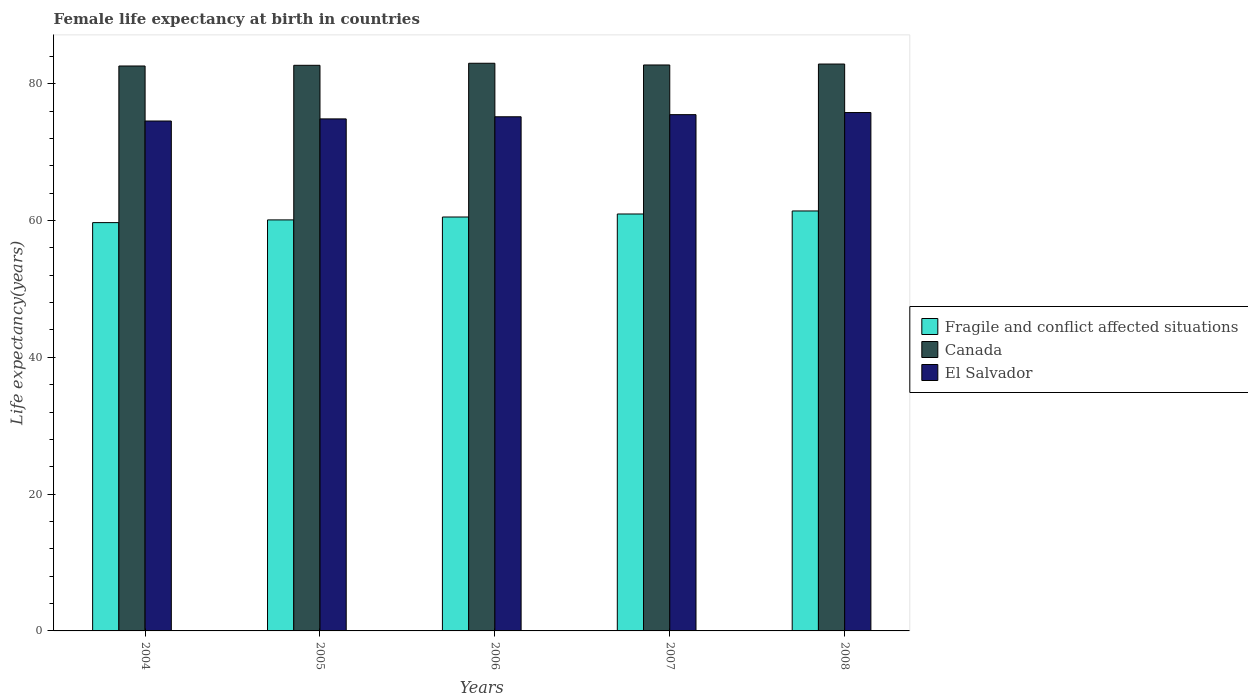Are the number of bars per tick equal to the number of legend labels?
Make the answer very short. Yes. How many bars are there on the 2nd tick from the left?
Your response must be concise. 3. How many bars are there on the 4th tick from the right?
Keep it short and to the point. 3. In how many cases, is the number of bars for a given year not equal to the number of legend labels?
Ensure brevity in your answer.  0. What is the female life expectancy at birth in Fragile and conflict affected situations in 2008?
Give a very brief answer. 61.4. Across all years, what is the maximum female life expectancy at birth in El Salvador?
Offer a terse response. 75.79. Across all years, what is the minimum female life expectancy at birth in Fragile and conflict affected situations?
Your response must be concise. 59.7. What is the total female life expectancy at birth in Canada in the graph?
Your answer should be very brief. 413.93. What is the difference between the female life expectancy at birth in Fragile and conflict affected situations in 2004 and that in 2005?
Keep it short and to the point. -0.4. What is the difference between the female life expectancy at birth in El Salvador in 2008 and the female life expectancy at birth in Fragile and conflict affected situations in 2005?
Make the answer very short. 15.7. What is the average female life expectancy at birth in Fragile and conflict affected situations per year?
Your answer should be very brief. 60.54. In the year 2005, what is the difference between the female life expectancy at birth in El Salvador and female life expectancy at birth in Canada?
Ensure brevity in your answer.  -7.84. What is the ratio of the female life expectancy at birth in Fragile and conflict affected situations in 2004 to that in 2007?
Offer a very short reply. 0.98. Is the female life expectancy at birth in Canada in 2005 less than that in 2006?
Your answer should be compact. Yes. What is the difference between the highest and the second highest female life expectancy at birth in El Salvador?
Make the answer very short. 0.31. What is the difference between the highest and the lowest female life expectancy at birth in Fragile and conflict affected situations?
Offer a very short reply. 1.71. In how many years, is the female life expectancy at birth in El Salvador greater than the average female life expectancy at birth in El Salvador taken over all years?
Keep it short and to the point. 3. Is the sum of the female life expectancy at birth in Fragile and conflict affected situations in 2004 and 2007 greater than the maximum female life expectancy at birth in El Salvador across all years?
Ensure brevity in your answer.  Yes. What does the 3rd bar from the left in 2007 represents?
Ensure brevity in your answer.  El Salvador. What does the 2nd bar from the right in 2005 represents?
Ensure brevity in your answer.  Canada. How many bars are there?
Ensure brevity in your answer.  15. How many years are there in the graph?
Provide a succinct answer. 5. What is the difference between two consecutive major ticks on the Y-axis?
Give a very brief answer. 20. Are the values on the major ticks of Y-axis written in scientific E-notation?
Provide a short and direct response. No. Where does the legend appear in the graph?
Offer a terse response. Center right. How many legend labels are there?
Offer a terse response. 3. How are the legend labels stacked?
Give a very brief answer. Vertical. What is the title of the graph?
Your answer should be very brief. Female life expectancy at birth in countries. What is the label or title of the X-axis?
Your response must be concise. Years. What is the label or title of the Y-axis?
Give a very brief answer. Life expectancy(years). What is the Life expectancy(years) of Fragile and conflict affected situations in 2004?
Ensure brevity in your answer.  59.7. What is the Life expectancy(years) in Canada in 2004?
Ensure brevity in your answer.  82.6. What is the Life expectancy(years) of El Salvador in 2004?
Offer a terse response. 74.56. What is the Life expectancy(years) of Fragile and conflict affected situations in 2005?
Give a very brief answer. 60.1. What is the Life expectancy(years) of Canada in 2005?
Ensure brevity in your answer.  82.7. What is the Life expectancy(years) of El Salvador in 2005?
Give a very brief answer. 74.86. What is the Life expectancy(years) of Fragile and conflict affected situations in 2006?
Ensure brevity in your answer.  60.52. What is the Life expectancy(years) of Canada in 2006?
Your answer should be very brief. 83. What is the Life expectancy(years) of El Salvador in 2006?
Your response must be concise. 75.18. What is the Life expectancy(years) of Fragile and conflict affected situations in 2007?
Offer a very short reply. 60.96. What is the Life expectancy(years) in Canada in 2007?
Make the answer very short. 82.75. What is the Life expectancy(years) of El Salvador in 2007?
Your response must be concise. 75.49. What is the Life expectancy(years) in Fragile and conflict affected situations in 2008?
Your response must be concise. 61.4. What is the Life expectancy(years) of Canada in 2008?
Your response must be concise. 82.89. What is the Life expectancy(years) of El Salvador in 2008?
Ensure brevity in your answer.  75.79. Across all years, what is the maximum Life expectancy(years) in Fragile and conflict affected situations?
Offer a very short reply. 61.4. Across all years, what is the maximum Life expectancy(years) in El Salvador?
Offer a terse response. 75.79. Across all years, what is the minimum Life expectancy(years) of Fragile and conflict affected situations?
Provide a succinct answer. 59.7. Across all years, what is the minimum Life expectancy(years) in Canada?
Provide a short and direct response. 82.6. Across all years, what is the minimum Life expectancy(years) of El Salvador?
Your answer should be compact. 74.56. What is the total Life expectancy(years) in Fragile and conflict affected situations in the graph?
Make the answer very short. 302.68. What is the total Life expectancy(years) of Canada in the graph?
Give a very brief answer. 413.93. What is the total Life expectancy(years) in El Salvador in the graph?
Your answer should be compact. 375.88. What is the difference between the Life expectancy(years) of Fragile and conflict affected situations in 2004 and that in 2005?
Keep it short and to the point. -0.4. What is the difference between the Life expectancy(years) of Canada in 2004 and that in 2005?
Your response must be concise. -0.1. What is the difference between the Life expectancy(years) in El Salvador in 2004 and that in 2005?
Give a very brief answer. -0.31. What is the difference between the Life expectancy(years) of Fragile and conflict affected situations in 2004 and that in 2006?
Make the answer very short. -0.82. What is the difference between the Life expectancy(years) in El Salvador in 2004 and that in 2006?
Offer a very short reply. -0.62. What is the difference between the Life expectancy(years) of Fragile and conflict affected situations in 2004 and that in 2007?
Provide a short and direct response. -1.26. What is the difference between the Life expectancy(years) in Canada in 2004 and that in 2007?
Ensure brevity in your answer.  -0.15. What is the difference between the Life expectancy(years) of El Salvador in 2004 and that in 2007?
Your answer should be compact. -0.93. What is the difference between the Life expectancy(years) of Fragile and conflict affected situations in 2004 and that in 2008?
Keep it short and to the point. -1.71. What is the difference between the Life expectancy(years) of Canada in 2004 and that in 2008?
Your response must be concise. -0.29. What is the difference between the Life expectancy(years) in El Salvador in 2004 and that in 2008?
Offer a very short reply. -1.24. What is the difference between the Life expectancy(years) in Fragile and conflict affected situations in 2005 and that in 2006?
Your response must be concise. -0.42. What is the difference between the Life expectancy(years) in Canada in 2005 and that in 2006?
Make the answer very short. -0.3. What is the difference between the Life expectancy(years) of El Salvador in 2005 and that in 2006?
Give a very brief answer. -0.31. What is the difference between the Life expectancy(years) of Fragile and conflict affected situations in 2005 and that in 2007?
Make the answer very short. -0.86. What is the difference between the Life expectancy(years) in Canada in 2005 and that in 2007?
Your response must be concise. -0.05. What is the difference between the Life expectancy(years) of El Salvador in 2005 and that in 2007?
Provide a succinct answer. -0.62. What is the difference between the Life expectancy(years) of Fragile and conflict affected situations in 2005 and that in 2008?
Provide a succinct answer. -1.31. What is the difference between the Life expectancy(years) of Canada in 2005 and that in 2008?
Ensure brevity in your answer.  -0.19. What is the difference between the Life expectancy(years) of El Salvador in 2005 and that in 2008?
Your response must be concise. -0.93. What is the difference between the Life expectancy(years) in Fragile and conflict affected situations in 2006 and that in 2007?
Make the answer very short. -0.44. What is the difference between the Life expectancy(years) of Canada in 2006 and that in 2007?
Provide a succinct answer. 0.25. What is the difference between the Life expectancy(years) of El Salvador in 2006 and that in 2007?
Give a very brief answer. -0.31. What is the difference between the Life expectancy(years) of Fragile and conflict affected situations in 2006 and that in 2008?
Provide a short and direct response. -0.88. What is the difference between the Life expectancy(years) in Canada in 2006 and that in 2008?
Provide a succinct answer. 0.11. What is the difference between the Life expectancy(years) in El Salvador in 2006 and that in 2008?
Your answer should be compact. -0.62. What is the difference between the Life expectancy(years) of Fragile and conflict affected situations in 2007 and that in 2008?
Keep it short and to the point. -0.45. What is the difference between the Life expectancy(years) in Canada in 2007 and that in 2008?
Make the answer very short. -0.14. What is the difference between the Life expectancy(years) in El Salvador in 2007 and that in 2008?
Give a very brief answer. -0.31. What is the difference between the Life expectancy(years) of Fragile and conflict affected situations in 2004 and the Life expectancy(years) of Canada in 2005?
Provide a succinct answer. -23. What is the difference between the Life expectancy(years) in Fragile and conflict affected situations in 2004 and the Life expectancy(years) in El Salvador in 2005?
Your answer should be very brief. -15.17. What is the difference between the Life expectancy(years) in Canada in 2004 and the Life expectancy(years) in El Salvador in 2005?
Your answer should be compact. 7.74. What is the difference between the Life expectancy(years) of Fragile and conflict affected situations in 2004 and the Life expectancy(years) of Canada in 2006?
Offer a terse response. -23.3. What is the difference between the Life expectancy(years) of Fragile and conflict affected situations in 2004 and the Life expectancy(years) of El Salvador in 2006?
Provide a short and direct response. -15.48. What is the difference between the Life expectancy(years) in Canada in 2004 and the Life expectancy(years) in El Salvador in 2006?
Offer a terse response. 7.42. What is the difference between the Life expectancy(years) of Fragile and conflict affected situations in 2004 and the Life expectancy(years) of Canada in 2007?
Give a very brief answer. -23.05. What is the difference between the Life expectancy(years) in Fragile and conflict affected situations in 2004 and the Life expectancy(years) in El Salvador in 2007?
Offer a very short reply. -15.79. What is the difference between the Life expectancy(years) of Canada in 2004 and the Life expectancy(years) of El Salvador in 2007?
Provide a short and direct response. 7.11. What is the difference between the Life expectancy(years) in Fragile and conflict affected situations in 2004 and the Life expectancy(years) in Canada in 2008?
Make the answer very short. -23.19. What is the difference between the Life expectancy(years) of Fragile and conflict affected situations in 2004 and the Life expectancy(years) of El Salvador in 2008?
Ensure brevity in your answer.  -16.09. What is the difference between the Life expectancy(years) of Canada in 2004 and the Life expectancy(years) of El Salvador in 2008?
Your response must be concise. 6.81. What is the difference between the Life expectancy(years) of Fragile and conflict affected situations in 2005 and the Life expectancy(years) of Canada in 2006?
Keep it short and to the point. -22.9. What is the difference between the Life expectancy(years) in Fragile and conflict affected situations in 2005 and the Life expectancy(years) in El Salvador in 2006?
Your response must be concise. -15.08. What is the difference between the Life expectancy(years) in Canada in 2005 and the Life expectancy(years) in El Salvador in 2006?
Provide a succinct answer. 7.52. What is the difference between the Life expectancy(years) of Fragile and conflict affected situations in 2005 and the Life expectancy(years) of Canada in 2007?
Offer a very short reply. -22.65. What is the difference between the Life expectancy(years) in Fragile and conflict affected situations in 2005 and the Life expectancy(years) in El Salvador in 2007?
Make the answer very short. -15.39. What is the difference between the Life expectancy(years) of Canada in 2005 and the Life expectancy(years) of El Salvador in 2007?
Your answer should be very brief. 7.21. What is the difference between the Life expectancy(years) of Fragile and conflict affected situations in 2005 and the Life expectancy(years) of Canada in 2008?
Your response must be concise. -22.79. What is the difference between the Life expectancy(years) in Fragile and conflict affected situations in 2005 and the Life expectancy(years) in El Salvador in 2008?
Your response must be concise. -15.7. What is the difference between the Life expectancy(years) in Canada in 2005 and the Life expectancy(years) in El Salvador in 2008?
Offer a very short reply. 6.91. What is the difference between the Life expectancy(years) of Fragile and conflict affected situations in 2006 and the Life expectancy(years) of Canada in 2007?
Make the answer very short. -22.23. What is the difference between the Life expectancy(years) of Fragile and conflict affected situations in 2006 and the Life expectancy(years) of El Salvador in 2007?
Make the answer very short. -14.97. What is the difference between the Life expectancy(years) in Canada in 2006 and the Life expectancy(years) in El Salvador in 2007?
Offer a terse response. 7.51. What is the difference between the Life expectancy(years) in Fragile and conflict affected situations in 2006 and the Life expectancy(years) in Canada in 2008?
Give a very brief answer. -22.37. What is the difference between the Life expectancy(years) in Fragile and conflict affected situations in 2006 and the Life expectancy(years) in El Salvador in 2008?
Make the answer very short. -15.27. What is the difference between the Life expectancy(years) in Canada in 2006 and the Life expectancy(years) in El Salvador in 2008?
Make the answer very short. 7.21. What is the difference between the Life expectancy(years) in Fragile and conflict affected situations in 2007 and the Life expectancy(years) in Canada in 2008?
Your response must be concise. -21.93. What is the difference between the Life expectancy(years) of Fragile and conflict affected situations in 2007 and the Life expectancy(years) of El Salvador in 2008?
Your answer should be very brief. -14.83. What is the difference between the Life expectancy(years) in Canada in 2007 and the Life expectancy(years) in El Salvador in 2008?
Provide a short and direct response. 6.95. What is the average Life expectancy(years) of Fragile and conflict affected situations per year?
Provide a short and direct response. 60.54. What is the average Life expectancy(years) of Canada per year?
Make the answer very short. 82.79. What is the average Life expectancy(years) of El Salvador per year?
Give a very brief answer. 75.18. In the year 2004, what is the difference between the Life expectancy(years) in Fragile and conflict affected situations and Life expectancy(years) in Canada?
Your answer should be very brief. -22.9. In the year 2004, what is the difference between the Life expectancy(years) in Fragile and conflict affected situations and Life expectancy(years) in El Salvador?
Offer a terse response. -14.86. In the year 2004, what is the difference between the Life expectancy(years) of Canada and Life expectancy(years) of El Salvador?
Offer a terse response. 8.04. In the year 2005, what is the difference between the Life expectancy(years) in Fragile and conflict affected situations and Life expectancy(years) in Canada?
Provide a succinct answer. -22.6. In the year 2005, what is the difference between the Life expectancy(years) in Fragile and conflict affected situations and Life expectancy(years) in El Salvador?
Provide a short and direct response. -14.77. In the year 2005, what is the difference between the Life expectancy(years) of Canada and Life expectancy(years) of El Salvador?
Your answer should be compact. 7.83. In the year 2006, what is the difference between the Life expectancy(years) of Fragile and conflict affected situations and Life expectancy(years) of Canada?
Ensure brevity in your answer.  -22.48. In the year 2006, what is the difference between the Life expectancy(years) in Fragile and conflict affected situations and Life expectancy(years) in El Salvador?
Offer a very short reply. -14.66. In the year 2006, what is the difference between the Life expectancy(years) in Canada and Life expectancy(years) in El Salvador?
Provide a succinct answer. 7.82. In the year 2007, what is the difference between the Life expectancy(years) of Fragile and conflict affected situations and Life expectancy(years) of Canada?
Your answer should be compact. -21.79. In the year 2007, what is the difference between the Life expectancy(years) of Fragile and conflict affected situations and Life expectancy(years) of El Salvador?
Make the answer very short. -14.53. In the year 2007, what is the difference between the Life expectancy(years) in Canada and Life expectancy(years) in El Salvador?
Your answer should be very brief. 7.26. In the year 2008, what is the difference between the Life expectancy(years) of Fragile and conflict affected situations and Life expectancy(years) of Canada?
Your response must be concise. -21.48. In the year 2008, what is the difference between the Life expectancy(years) in Fragile and conflict affected situations and Life expectancy(years) in El Salvador?
Offer a very short reply. -14.39. In the year 2008, what is the difference between the Life expectancy(years) in Canada and Life expectancy(years) in El Salvador?
Your response must be concise. 7.09. What is the ratio of the Life expectancy(years) in Canada in 2004 to that in 2005?
Ensure brevity in your answer.  1. What is the ratio of the Life expectancy(years) in Fragile and conflict affected situations in 2004 to that in 2006?
Give a very brief answer. 0.99. What is the ratio of the Life expectancy(years) in El Salvador in 2004 to that in 2006?
Your answer should be very brief. 0.99. What is the ratio of the Life expectancy(years) of Fragile and conflict affected situations in 2004 to that in 2007?
Provide a succinct answer. 0.98. What is the ratio of the Life expectancy(years) in Fragile and conflict affected situations in 2004 to that in 2008?
Your answer should be compact. 0.97. What is the ratio of the Life expectancy(years) of El Salvador in 2004 to that in 2008?
Keep it short and to the point. 0.98. What is the ratio of the Life expectancy(years) of Fragile and conflict affected situations in 2005 to that in 2006?
Your answer should be compact. 0.99. What is the ratio of the Life expectancy(years) of Fragile and conflict affected situations in 2005 to that in 2007?
Keep it short and to the point. 0.99. What is the ratio of the Life expectancy(years) of Canada in 2005 to that in 2007?
Offer a terse response. 1. What is the ratio of the Life expectancy(years) of El Salvador in 2005 to that in 2007?
Make the answer very short. 0.99. What is the ratio of the Life expectancy(years) in Fragile and conflict affected situations in 2005 to that in 2008?
Your answer should be very brief. 0.98. What is the ratio of the Life expectancy(years) in Fragile and conflict affected situations in 2006 to that in 2007?
Your answer should be very brief. 0.99. What is the ratio of the Life expectancy(years) of Canada in 2006 to that in 2007?
Make the answer very short. 1. What is the ratio of the Life expectancy(years) in Fragile and conflict affected situations in 2006 to that in 2008?
Make the answer very short. 0.99. What is the ratio of the Life expectancy(years) in El Salvador in 2006 to that in 2008?
Your answer should be very brief. 0.99. What is the ratio of the Life expectancy(years) of Canada in 2007 to that in 2008?
Offer a very short reply. 1. What is the difference between the highest and the second highest Life expectancy(years) in Fragile and conflict affected situations?
Provide a short and direct response. 0.45. What is the difference between the highest and the second highest Life expectancy(years) in Canada?
Your answer should be very brief. 0.11. What is the difference between the highest and the second highest Life expectancy(years) in El Salvador?
Give a very brief answer. 0.31. What is the difference between the highest and the lowest Life expectancy(years) of Fragile and conflict affected situations?
Offer a terse response. 1.71. What is the difference between the highest and the lowest Life expectancy(years) of El Salvador?
Offer a very short reply. 1.24. 